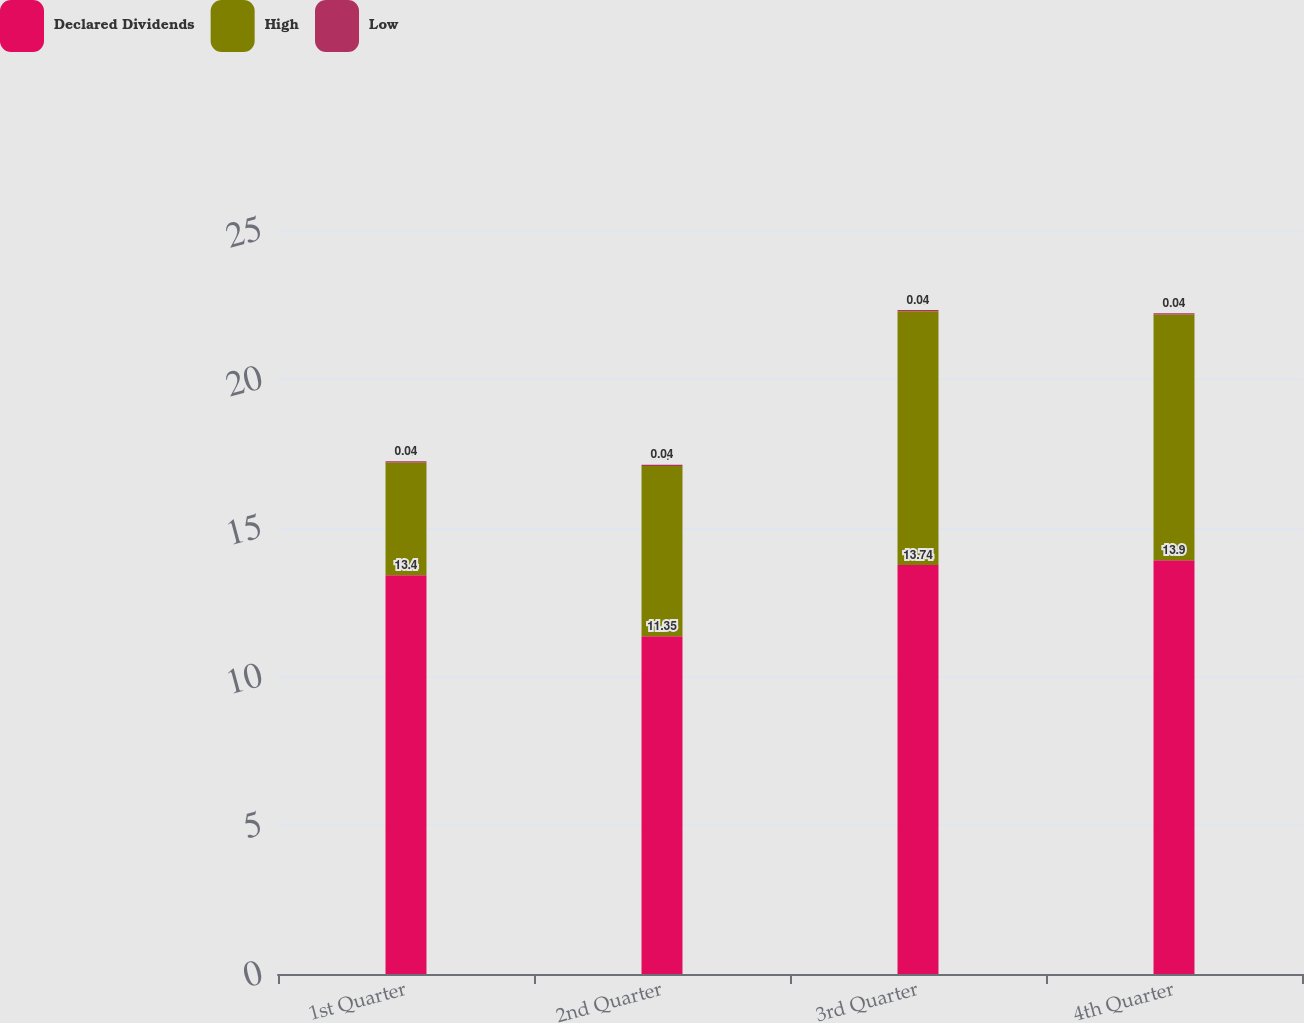<chart> <loc_0><loc_0><loc_500><loc_500><stacked_bar_chart><ecel><fcel>1st Quarter<fcel>2nd Quarter<fcel>3rd Quarter<fcel>4th Quarter<nl><fcel>Declared Dividends<fcel>13.4<fcel>11.35<fcel>13.74<fcel>13.9<nl><fcel>High<fcel>3.79<fcel>5.72<fcel>8.53<fcel>8.26<nl><fcel>Low<fcel>0.04<fcel>0.04<fcel>0.04<fcel>0.04<nl></chart> 